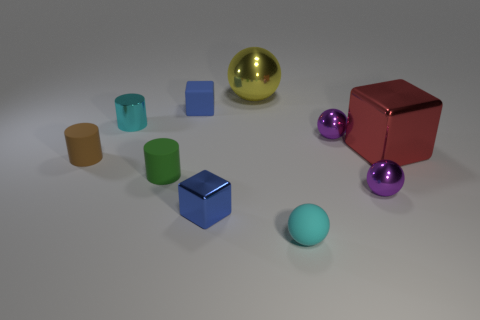Is there any other thing that is the same color as the tiny rubber sphere?
Offer a terse response. Yes. Do the brown cylinder and the large yellow ball have the same material?
Offer a very short reply. No. How many shiny blocks are in front of the small purple sphere in front of the rubber cylinder that is to the left of the shiny cylinder?
Your response must be concise. 1. How many yellow balls are there?
Ensure brevity in your answer.  1. Are there fewer brown rubber cylinders that are behind the tiny cyan shiny cylinder than cyan metal things in front of the big ball?
Give a very brief answer. Yes. Is the number of cyan matte things on the left side of the green rubber object less than the number of tiny cyan objects?
Provide a short and direct response. Yes. There is a small block that is behind the small cube in front of the tiny block that is behind the red metal cube; what is its material?
Your response must be concise. Rubber. What number of objects are small cyan objects on the left side of the tiny cyan rubber object or things to the left of the large red cube?
Provide a short and direct response. 9. What material is the tiny cyan thing that is the same shape as the tiny green thing?
Offer a terse response. Metal. What number of rubber things are small brown cylinders or tiny green cylinders?
Provide a short and direct response. 2. 